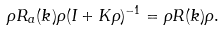Convert formula to latex. <formula><loc_0><loc_0><loc_500><loc_500>\rho R _ { a } ( k ) \rho ( I + K \rho ) ^ { - 1 } = \rho R ( k ) \rho .</formula> 